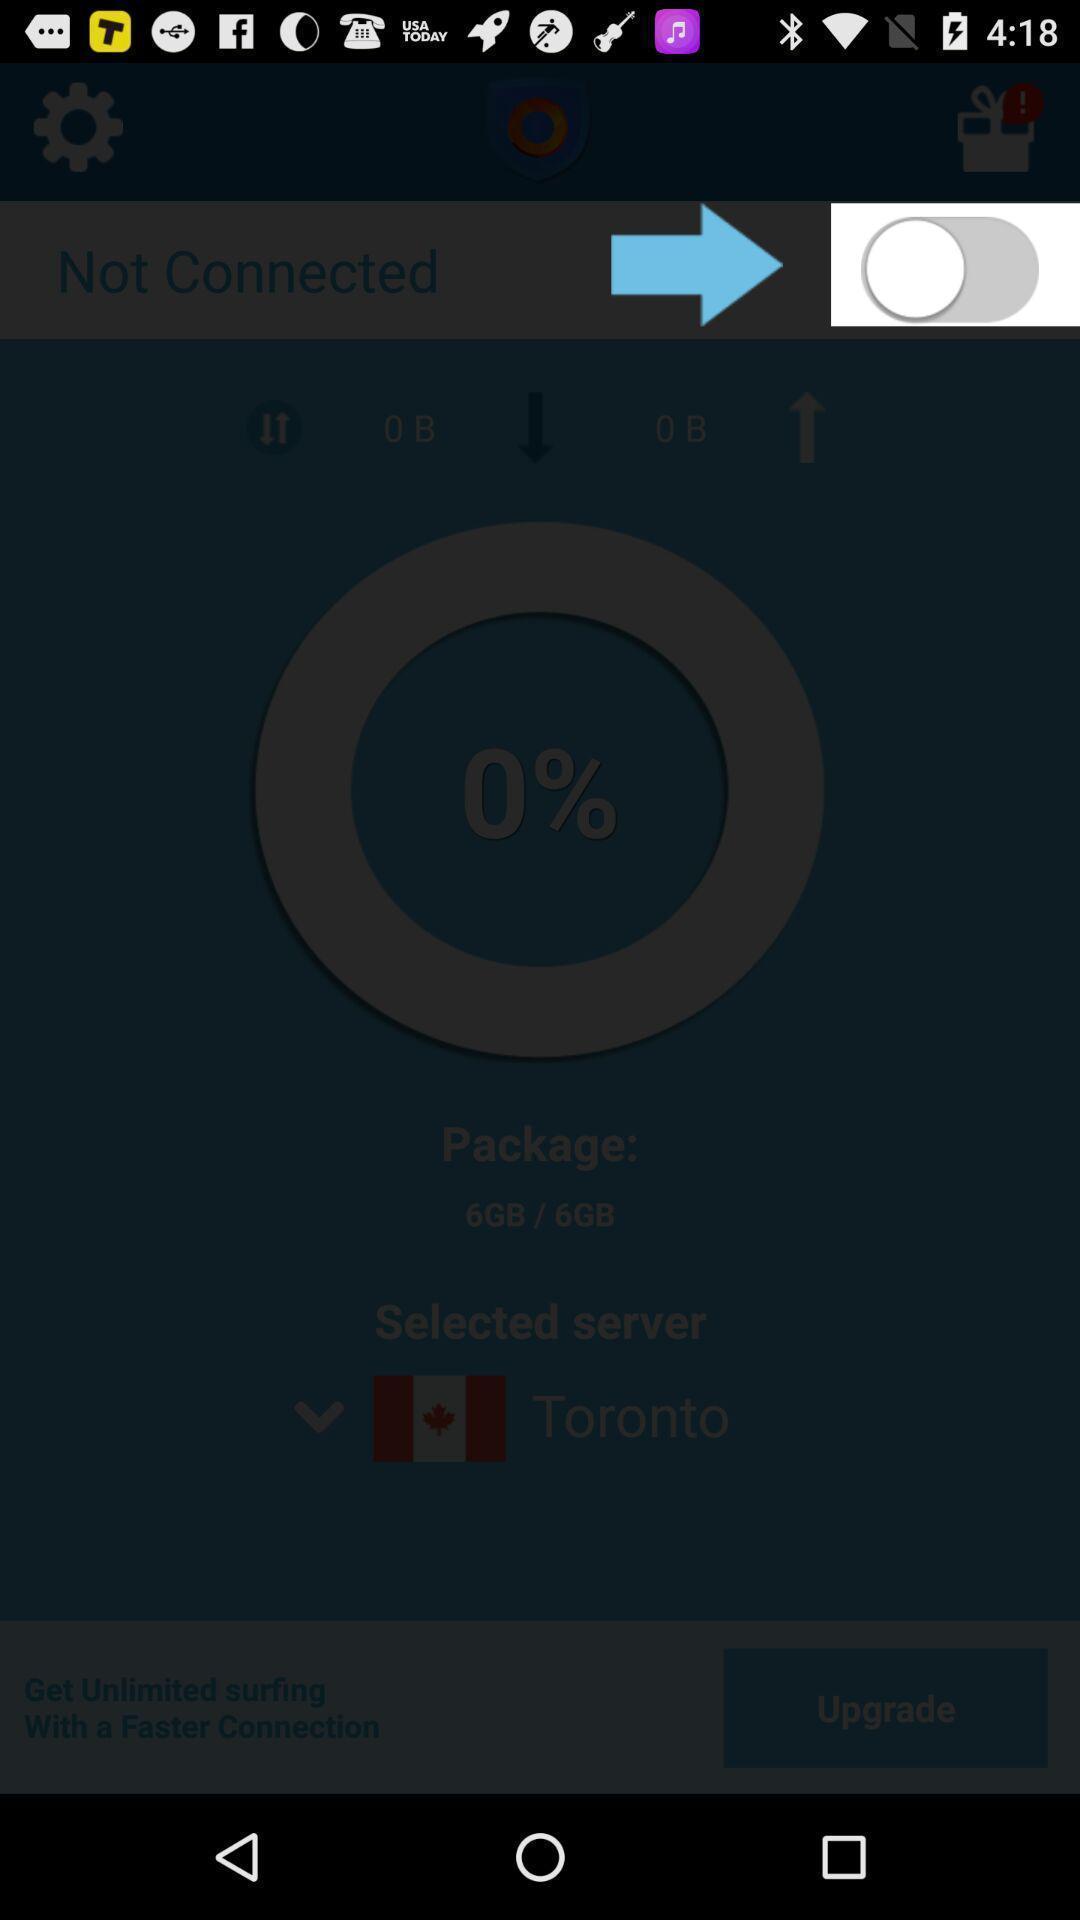What can you discern from this picture? Screen displaying the toggle icon. 